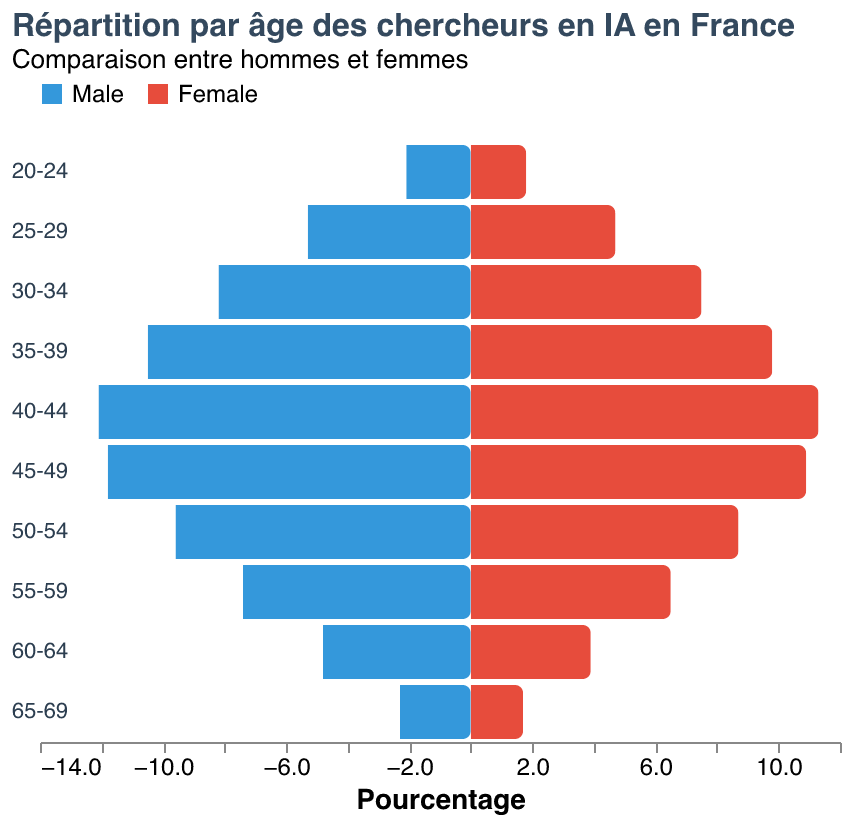What is the age group with the highest percentage of male AI researchers in France? The age group with the highest percentage of male AI researchers can be determined by comparing the heights of the blue bars representing male percentages across different age groups. The tallest blue bar indicates the age group 40-44 has the highest male percentage.
Answer: 40-44 How does the percentage of female AI researchers in the age group 35-39 compare to that in the age group 25-29? To compare the percentages, we look at the height of the red bars for the two age groups. The percentage for females in the age group 35-39 is 9.8%, while it is 4.7% for the age group 25-29. Therefore, the percentage is higher in the age group 35-39.
Answer: 35-39 has a higher percentage How many age groups see a higher percentage of male AI researchers than females? Count the number of age groups where the blue bar (male percentage) is taller than the red bar (female percentage). This applies to all age groups from 20-24 to 65-69, giving a total of 10 age groups.
Answer: 10 What is the difference in percentage between male and female AI researchers in the age group 40-44? The male percentage in the age group 40-44 is 12.1%, and the female percentage is 11.3%. Subtracting the female percentage from the male percentage gives 12.1% - 11.3% = 0.8%.
Answer: 0.8% Which age group has the smallest difference between male and female percentages for AI researchers? Compare the difference in percentages for each age group by subtracting the female percentage from the male percentage. The smallest difference is observed in the age group 40-44, with a difference of 0.8%.
Answer: 40-44 Is there any age group where the percentage of female AI researchers exceeds the percentage of male researchers? By visually comparing the lengths of the red and blue bars for each age group, it is evident that the blue bars are always taller, indicating no age group has a higher percentage of female researchers.
Answer: No What is the trend in the percentage of female AI researchers as the age increases from 20-69? Observing the height of red bars from the youngest age group to the oldest, there is an increase in percentages up to the age group 40-44, followed by a decrease in percentages as age increases further.
Answer: Increase then decrease What percentage of AI researchers are males in the 50-54 age group? Find the value associated with the blue bar for the 50-54 age group. The value for males in that group is 9.6%.
Answer: 9.6% Which age group has the highest overall percentage of AI researchers when combining both male and female percentages? Add the percentages of males and females for each age group and compare the sums. The 40-44 age group has the highest combined percentage with 12.1% (male) + 11.3% (female) = 23.4%.
Answer: 40-44 How does the percentage of male AI researchers in the 65-69 age group compare to that in the 20-24 age group? Compare the male percentages of these two age groups by looking at the blue bars. The 65-69 age group has 2.3%, while the 20-24 age group has 2.1%. Therefore, the percentage is slightly higher in the 65-69 age group.
Answer: Higher in 65-69 